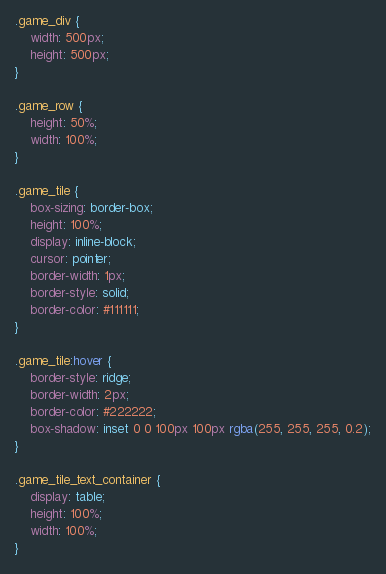<code> <loc_0><loc_0><loc_500><loc_500><_CSS_>.game_div {
    width: 500px;
    height: 500px;
}

.game_row {
    height: 50%;
    width: 100%;
}

.game_tile {
    box-sizing: border-box;
    height: 100%;
    display: inline-block;
    cursor: pointer;
    border-width: 1px;
    border-style: solid;
    border-color: #111111;
}

.game_tile:hover {
    border-style: ridge;
    border-width: 2px;
    border-color: #222222;
    box-shadow: inset 0 0 100px 100px rgba(255, 255, 255, 0.2);
}

.game_tile_text_container {
    display: table;
    height: 100%;
    width: 100%;
}
</code> 